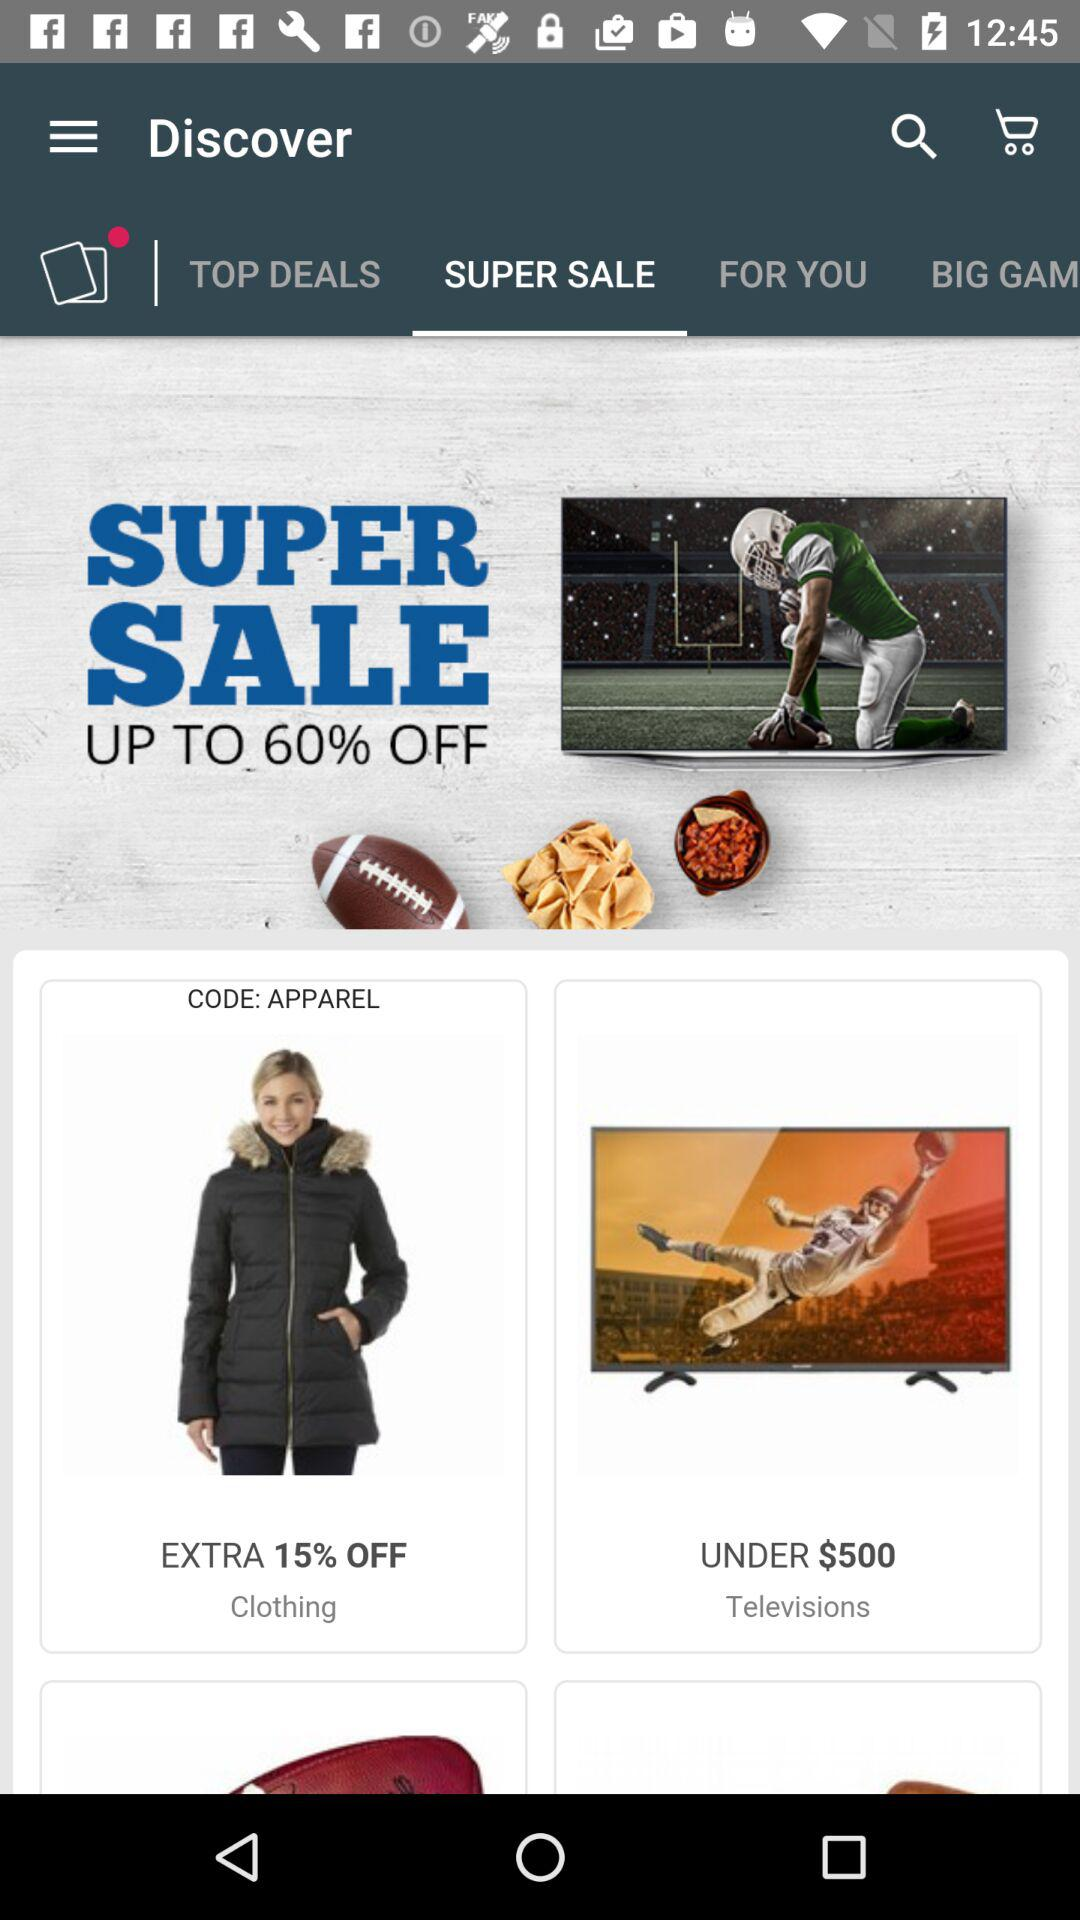What's the maximum price for television? The maximum price for a television is $500. 